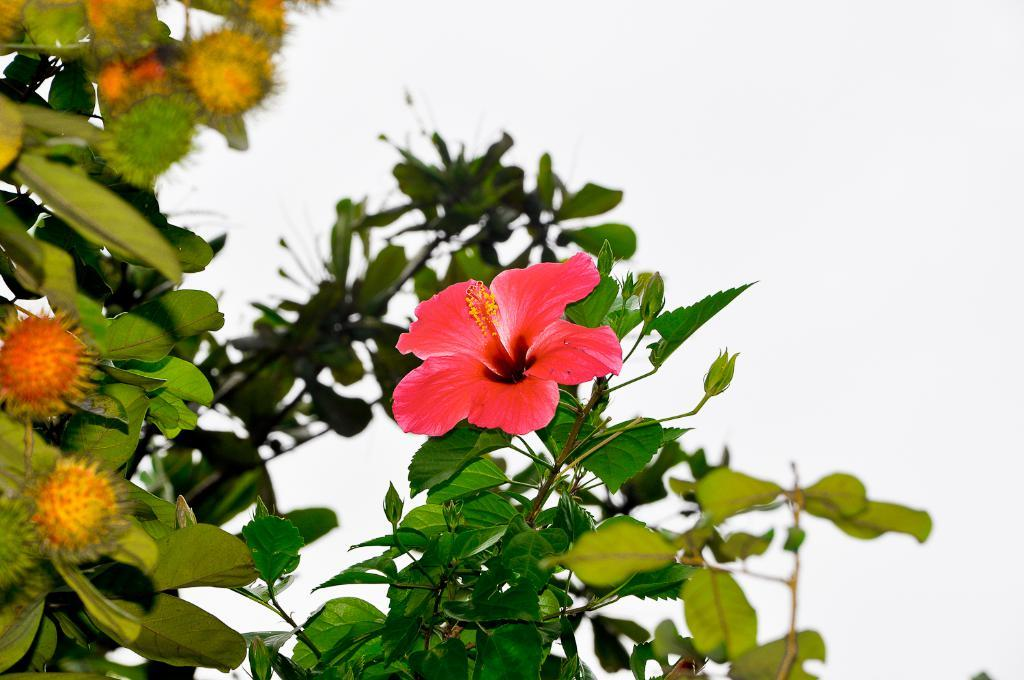What is the main subject of the image? The main subject of the image is a flower. Where is the flower located? The flower is on a plant. What can be seen in the background of the image? The sky is visible in the background of the image. What type of nail is being used to hang the flower in the image? There is no nail present in the image, and the flower is not hanging; it is on a plant. How is the daughter interacting with the flower in the image? There is no daughter present in the image, and the flower is on a plant, not interacting with any person. 